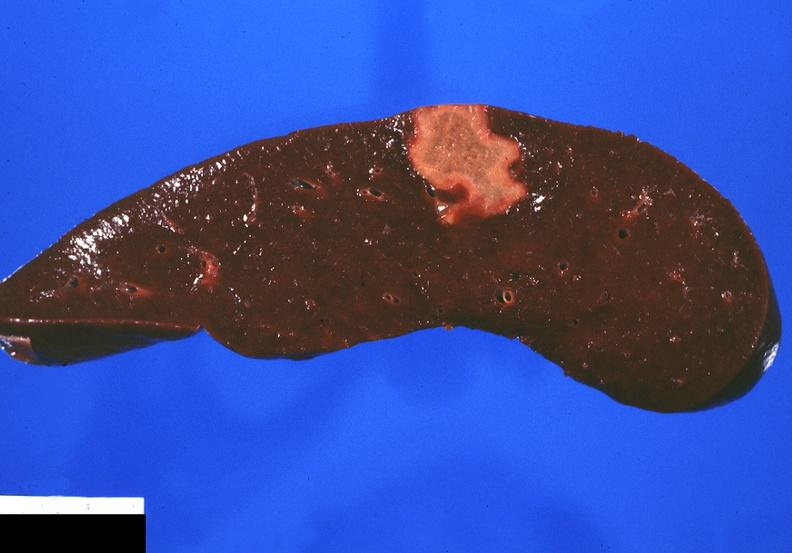what is present?
Answer the question using a single word or phrase. Hematologic 